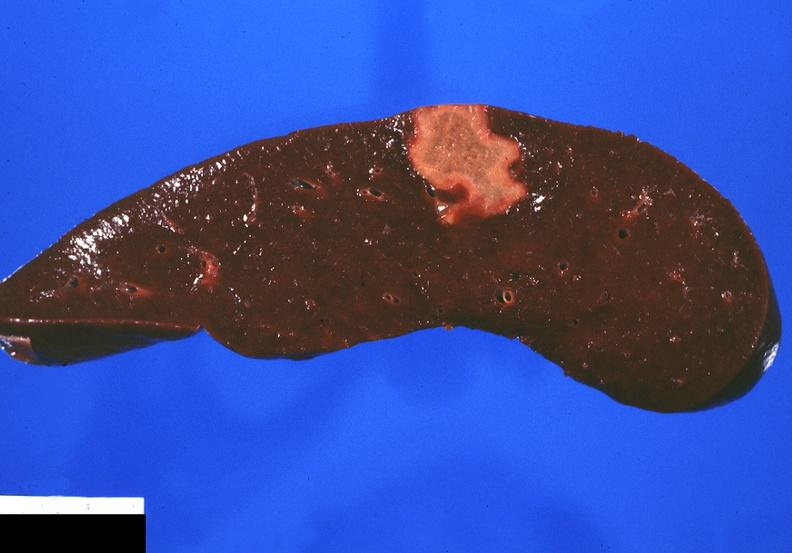what is present?
Answer the question using a single word or phrase. Hematologic 